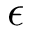<formula> <loc_0><loc_0><loc_500><loc_500>\epsilon</formula> 